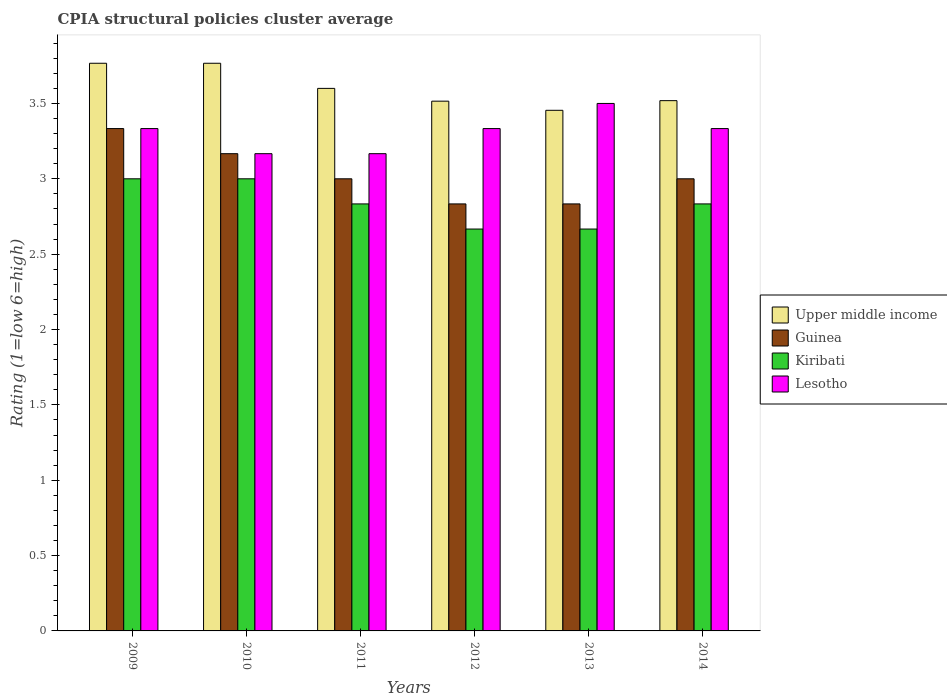How many different coloured bars are there?
Your answer should be compact. 4. How many groups of bars are there?
Offer a very short reply. 6. What is the label of the 2nd group of bars from the left?
Ensure brevity in your answer.  2010. In how many cases, is the number of bars for a given year not equal to the number of legend labels?
Your answer should be compact. 0. What is the CPIA rating in Guinea in 2014?
Offer a very short reply. 3. Across all years, what is the maximum CPIA rating in Upper middle income?
Offer a very short reply. 3.77. Across all years, what is the minimum CPIA rating in Guinea?
Provide a short and direct response. 2.83. In which year was the CPIA rating in Lesotho maximum?
Your answer should be very brief. 2013. What is the total CPIA rating in Upper middle income in the graph?
Your answer should be very brief. 21.62. What is the difference between the CPIA rating in Guinea in 2009 and that in 2013?
Provide a short and direct response. 0.5. What is the difference between the CPIA rating in Upper middle income in 2014 and the CPIA rating in Lesotho in 2009?
Make the answer very short. 0.19. What is the average CPIA rating in Lesotho per year?
Your response must be concise. 3.31. In the year 2014, what is the difference between the CPIA rating in Kiribati and CPIA rating in Guinea?
Keep it short and to the point. -0.17. In how many years, is the CPIA rating in Guinea greater than 3.1?
Keep it short and to the point. 2. What is the ratio of the CPIA rating in Upper middle income in 2011 to that in 2014?
Provide a succinct answer. 1.02. Is the CPIA rating in Kiribati in 2010 less than that in 2014?
Your response must be concise. No. What is the difference between the highest and the lowest CPIA rating in Lesotho?
Your answer should be compact. 0.33. Is the sum of the CPIA rating in Kiribati in 2013 and 2014 greater than the maximum CPIA rating in Lesotho across all years?
Your answer should be very brief. Yes. What does the 4th bar from the left in 2012 represents?
Offer a terse response. Lesotho. What does the 3rd bar from the right in 2013 represents?
Ensure brevity in your answer.  Guinea. How many bars are there?
Make the answer very short. 24. Are all the bars in the graph horizontal?
Ensure brevity in your answer.  No. How many years are there in the graph?
Make the answer very short. 6. What is the difference between two consecutive major ticks on the Y-axis?
Give a very brief answer. 0.5. Are the values on the major ticks of Y-axis written in scientific E-notation?
Provide a succinct answer. No. Does the graph contain any zero values?
Your answer should be very brief. No. What is the title of the graph?
Provide a short and direct response. CPIA structural policies cluster average. What is the label or title of the X-axis?
Make the answer very short. Years. What is the Rating (1=low 6=high) of Upper middle income in 2009?
Keep it short and to the point. 3.77. What is the Rating (1=low 6=high) in Guinea in 2009?
Offer a very short reply. 3.33. What is the Rating (1=low 6=high) in Lesotho in 2009?
Keep it short and to the point. 3.33. What is the Rating (1=low 6=high) of Upper middle income in 2010?
Offer a very short reply. 3.77. What is the Rating (1=low 6=high) of Guinea in 2010?
Ensure brevity in your answer.  3.17. What is the Rating (1=low 6=high) of Lesotho in 2010?
Your answer should be compact. 3.17. What is the Rating (1=low 6=high) in Upper middle income in 2011?
Ensure brevity in your answer.  3.6. What is the Rating (1=low 6=high) in Guinea in 2011?
Provide a short and direct response. 3. What is the Rating (1=low 6=high) in Kiribati in 2011?
Your response must be concise. 2.83. What is the Rating (1=low 6=high) of Lesotho in 2011?
Offer a very short reply. 3.17. What is the Rating (1=low 6=high) of Upper middle income in 2012?
Provide a succinct answer. 3.52. What is the Rating (1=low 6=high) in Guinea in 2012?
Make the answer very short. 2.83. What is the Rating (1=low 6=high) in Kiribati in 2012?
Provide a succinct answer. 2.67. What is the Rating (1=low 6=high) in Lesotho in 2012?
Offer a terse response. 3.33. What is the Rating (1=low 6=high) of Upper middle income in 2013?
Give a very brief answer. 3.45. What is the Rating (1=low 6=high) in Guinea in 2013?
Offer a terse response. 2.83. What is the Rating (1=low 6=high) in Kiribati in 2013?
Ensure brevity in your answer.  2.67. What is the Rating (1=low 6=high) in Upper middle income in 2014?
Your answer should be compact. 3.52. What is the Rating (1=low 6=high) in Kiribati in 2014?
Provide a short and direct response. 2.83. What is the Rating (1=low 6=high) in Lesotho in 2014?
Offer a very short reply. 3.33. Across all years, what is the maximum Rating (1=low 6=high) in Upper middle income?
Give a very brief answer. 3.77. Across all years, what is the maximum Rating (1=low 6=high) of Guinea?
Provide a succinct answer. 3.33. Across all years, what is the maximum Rating (1=low 6=high) in Kiribati?
Keep it short and to the point. 3. Across all years, what is the minimum Rating (1=low 6=high) in Upper middle income?
Give a very brief answer. 3.45. Across all years, what is the minimum Rating (1=low 6=high) in Guinea?
Offer a terse response. 2.83. Across all years, what is the minimum Rating (1=low 6=high) in Kiribati?
Keep it short and to the point. 2.67. Across all years, what is the minimum Rating (1=low 6=high) in Lesotho?
Offer a terse response. 3.17. What is the total Rating (1=low 6=high) of Upper middle income in the graph?
Provide a succinct answer. 21.62. What is the total Rating (1=low 6=high) in Guinea in the graph?
Make the answer very short. 18.17. What is the total Rating (1=low 6=high) of Lesotho in the graph?
Offer a very short reply. 19.83. What is the difference between the Rating (1=low 6=high) in Guinea in 2009 and that in 2010?
Offer a very short reply. 0.17. What is the difference between the Rating (1=low 6=high) in Lesotho in 2009 and that in 2010?
Give a very brief answer. 0.17. What is the difference between the Rating (1=low 6=high) in Upper middle income in 2009 and that in 2012?
Your answer should be very brief. 0.25. What is the difference between the Rating (1=low 6=high) of Guinea in 2009 and that in 2012?
Ensure brevity in your answer.  0.5. What is the difference between the Rating (1=low 6=high) in Kiribati in 2009 and that in 2012?
Your answer should be very brief. 0.33. What is the difference between the Rating (1=low 6=high) in Upper middle income in 2009 and that in 2013?
Give a very brief answer. 0.31. What is the difference between the Rating (1=low 6=high) of Guinea in 2009 and that in 2013?
Provide a succinct answer. 0.5. What is the difference between the Rating (1=low 6=high) in Kiribati in 2009 and that in 2013?
Provide a succinct answer. 0.33. What is the difference between the Rating (1=low 6=high) of Lesotho in 2009 and that in 2013?
Provide a succinct answer. -0.17. What is the difference between the Rating (1=low 6=high) in Upper middle income in 2009 and that in 2014?
Provide a short and direct response. 0.25. What is the difference between the Rating (1=low 6=high) in Guinea in 2009 and that in 2014?
Make the answer very short. 0.33. What is the difference between the Rating (1=low 6=high) in Kiribati in 2009 and that in 2014?
Your answer should be very brief. 0.17. What is the difference between the Rating (1=low 6=high) in Upper middle income in 2010 and that in 2011?
Make the answer very short. 0.17. What is the difference between the Rating (1=low 6=high) of Upper middle income in 2010 and that in 2012?
Provide a succinct answer. 0.25. What is the difference between the Rating (1=low 6=high) in Guinea in 2010 and that in 2012?
Give a very brief answer. 0.33. What is the difference between the Rating (1=low 6=high) in Kiribati in 2010 and that in 2012?
Give a very brief answer. 0.33. What is the difference between the Rating (1=low 6=high) in Lesotho in 2010 and that in 2012?
Keep it short and to the point. -0.17. What is the difference between the Rating (1=low 6=high) in Upper middle income in 2010 and that in 2013?
Offer a terse response. 0.31. What is the difference between the Rating (1=low 6=high) of Upper middle income in 2010 and that in 2014?
Your answer should be compact. 0.25. What is the difference between the Rating (1=low 6=high) of Guinea in 2010 and that in 2014?
Provide a succinct answer. 0.17. What is the difference between the Rating (1=low 6=high) of Lesotho in 2010 and that in 2014?
Provide a succinct answer. -0.17. What is the difference between the Rating (1=low 6=high) in Upper middle income in 2011 and that in 2012?
Your answer should be compact. 0.08. What is the difference between the Rating (1=low 6=high) in Kiribati in 2011 and that in 2012?
Provide a short and direct response. 0.17. What is the difference between the Rating (1=low 6=high) of Lesotho in 2011 and that in 2012?
Offer a very short reply. -0.17. What is the difference between the Rating (1=low 6=high) of Upper middle income in 2011 and that in 2013?
Offer a very short reply. 0.15. What is the difference between the Rating (1=low 6=high) in Upper middle income in 2011 and that in 2014?
Provide a succinct answer. 0.08. What is the difference between the Rating (1=low 6=high) in Lesotho in 2011 and that in 2014?
Offer a very short reply. -0.17. What is the difference between the Rating (1=low 6=high) in Upper middle income in 2012 and that in 2013?
Keep it short and to the point. 0.06. What is the difference between the Rating (1=low 6=high) in Lesotho in 2012 and that in 2013?
Your response must be concise. -0.17. What is the difference between the Rating (1=low 6=high) of Upper middle income in 2012 and that in 2014?
Provide a short and direct response. -0. What is the difference between the Rating (1=low 6=high) of Lesotho in 2012 and that in 2014?
Make the answer very short. 0. What is the difference between the Rating (1=low 6=high) of Upper middle income in 2013 and that in 2014?
Provide a short and direct response. -0.06. What is the difference between the Rating (1=low 6=high) of Kiribati in 2013 and that in 2014?
Your response must be concise. -0.17. What is the difference between the Rating (1=low 6=high) of Upper middle income in 2009 and the Rating (1=low 6=high) of Guinea in 2010?
Keep it short and to the point. 0.6. What is the difference between the Rating (1=low 6=high) in Upper middle income in 2009 and the Rating (1=low 6=high) in Kiribati in 2010?
Your response must be concise. 0.77. What is the difference between the Rating (1=low 6=high) in Guinea in 2009 and the Rating (1=low 6=high) in Kiribati in 2010?
Keep it short and to the point. 0.33. What is the difference between the Rating (1=low 6=high) of Upper middle income in 2009 and the Rating (1=low 6=high) of Guinea in 2011?
Your answer should be compact. 0.77. What is the difference between the Rating (1=low 6=high) in Upper middle income in 2009 and the Rating (1=low 6=high) in Kiribati in 2011?
Keep it short and to the point. 0.93. What is the difference between the Rating (1=low 6=high) in Upper middle income in 2009 and the Rating (1=low 6=high) in Lesotho in 2011?
Your answer should be compact. 0.6. What is the difference between the Rating (1=low 6=high) in Guinea in 2009 and the Rating (1=low 6=high) in Kiribati in 2011?
Provide a succinct answer. 0.5. What is the difference between the Rating (1=low 6=high) in Guinea in 2009 and the Rating (1=low 6=high) in Lesotho in 2011?
Keep it short and to the point. 0.17. What is the difference between the Rating (1=low 6=high) in Kiribati in 2009 and the Rating (1=low 6=high) in Lesotho in 2011?
Offer a terse response. -0.17. What is the difference between the Rating (1=low 6=high) in Upper middle income in 2009 and the Rating (1=low 6=high) in Lesotho in 2012?
Make the answer very short. 0.43. What is the difference between the Rating (1=low 6=high) of Guinea in 2009 and the Rating (1=low 6=high) of Kiribati in 2012?
Offer a terse response. 0.67. What is the difference between the Rating (1=low 6=high) of Guinea in 2009 and the Rating (1=low 6=high) of Lesotho in 2012?
Give a very brief answer. 0. What is the difference between the Rating (1=low 6=high) in Kiribati in 2009 and the Rating (1=low 6=high) in Lesotho in 2012?
Ensure brevity in your answer.  -0.33. What is the difference between the Rating (1=low 6=high) in Upper middle income in 2009 and the Rating (1=low 6=high) in Guinea in 2013?
Your answer should be very brief. 0.93. What is the difference between the Rating (1=low 6=high) of Upper middle income in 2009 and the Rating (1=low 6=high) of Kiribati in 2013?
Ensure brevity in your answer.  1.1. What is the difference between the Rating (1=low 6=high) in Upper middle income in 2009 and the Rating (1=low 6=high) in Lesotho in 2013?
Offer a terse response. 0.27. What is the difference between the Rating (1=low 6=high) in Guinea in 2009 and the Rating (1=low 6=high) in Kiribati in 2013?
Your answer should be very brief. 0.67. What is the difference between the Rating (1=low 6=high) in Guinea in 2009 and the Rating (1=low 6=high) in Lesotho in 2013?
Offer a terse response. -0.17. What is the difference between the Rating (1=low 6=high) in Upper middle income in 2009 and the Rating (1=low 6=high) in Guinea in 2014?
Keep it short and to the point. 0.77. What is the difference between the Rating (1=low 6=high) of Upper middle income in 2009 and the Rating (1=low 6=high) of Kiribati in 2014?
Your response must be concise. 0.93. What is the difference between the Rating (1=low 6=high) of Upper middle income in 2009 and the Rating (1=low 6=high) of Lesotho in 2014?
Offer a very short reply. 0.43. What is the difference between the Rating (1=low 6=high) of Guinea in 2009 and the Rating (1=low 6=high) of Lesotho in 2014?
Give a very brief answer. 0. What is the difference between the Rating (1=low 6=high) of Kiribati in 2009 and the Rating (1=low 6=high) of Lesotho in 2014?
Provide a succinct answer. -0.33. What is the difference between the Rating (1=low 6=high) of Upper middle income in 2010 and the Rating (1=low 6=high) of Guinea in 2011?
Make the answer very short. 0.77. What is the difference between the Rating (1=low 6=high) in Upper middle income in 2010 and the Rating (1=low 6=high) in Lesotho in 2011?
Make the answer very short. 0.6. What is the difference between the Rating (1=low 6=high) of Guinea in 2010 and the Rating (1=low 6=high) of Kiribati in 2011?
Keep it short and to the point. 0.33. What is the difference between the Rating (1=low 6=high) of Guinea in 2010 and the Rating (1=low 6=high) of Lesotho in 2011?
Give a very brief answer. 0. What is the difference between the Rating (1=low 6=high) in Upper middle income in 2010 and the Rating (1=low 6=high) in Kiribati in 2012?
Provide a succinct answer. 1.1. What is the difference between the Rating (1=low 6=high) of Upper middle income in 2010 and the Rating (1=low 6=high) of Lesotho in 2012?
Keep it short and to the point. 0.43. What is the difference between the Rating (1=low 6=high) of Guinea in 2010 and the Rating (1=low 6=high) of Lesotho in 2012?
Offer a terse response. -0.17. What is the difference between the Rating (1=low 6=high) in Kiribati in 2010 and the Rating (1=low 6=high) in Lesotho in 2012?
Your answer should be very brief. -0.33. What is the difference between the Rating (1=low 6=high) in Upper middle income in 2010 and the Rating (1=low 6=high) in Guinea in 2013?
Provide a short and direct response. 0.93. What is the difference between the Rating (1=low 6=high) of Upper middle income in 2010 and the Rating (1=low 6=high) of Lesotho in 2013?
Provide a short and direct response. 0.27. What is the difference between the Rating (1=low 6=high) in Guinea in 2010 and the Rating (1=low 6=high) in Lesotho in 2013?
Offer a terse response. -0.33. What is the difference between the Rating (1=low 6=high) in Kiribati in 2010 and the Rating (1=low 6=high) in Lesotho in 2013?
Keep it short and to the point. -0.5. What is the difference between the Rating (1=low 6=high) of Upper middle income in 2010 and the Rating (1=low 6=high) of Guinea in 2014?
Your answer should be very brief. 0.77. What is the difference between the Rating (1=low 6=high) of Upper middle income in 2010 and the Rating (1=low 6=high) of Lesotho in 2014?
Your answer should be very brief. 0.43. What is the difference between the Rating (1=low 6=high) in Guinea in 2010 and the Rating (1=low 6=high) in Kiribati in 2014?
Make the answer very short. 0.33. What is the difference between the Rating (1=low 6=high) of Guinea in 2010 and the Rating (1=low 6=high) of Lesotho in 2014?
Keep it short and to the point. -0.17. What is the difference between the Rating (1=low 6=high) of Upper middle income in 2011 and the Rating (1=low 6=high) of Guinea in 2012?
Keep it short and to the point. 0.77. What is the difference between the Rating (1=low 6=high) in Upper middle income in 2011 and the Rating (1=low 6=high) in Kiribati in 2012?
Your response must be concise. 0.93. What is the difference between the Rating (1=low 6=high) in Upper middle income in 2011 and the Rating (1=low 6=high) in Lesotho in 2012?
Provide a succinct answer. 0.27. What is the difference between the Rating (1=low 6=high) in Upper middle income in 2011 and the Rating (1=low 6=high) in Guinea in 2013?
Make the answer very short. 0.77. What is the difference between the Rating (1=low 6=high) of Upper middle income in 2011 and the Rating (1=low 6=high) of Lesotho in 2013?
Make the answer very short. 0.1. What is the difference between the Rating (1=low 6=high) of Guinea in 2011 and the Rating (1=low 6=high) of Lesotho in 2013?
Make the answer very short. -0.5. What is the difference between the Rating (1=low 6=high) of Kiribati in 2011 and the Rating (1=low 6=high) of Lesotho in 2013?
Provide a succinct answer. -0.67. What is the difference between the Rating (1=low 6=high) in Upper middle income in 2011 and the Rating (1=low 6=high) in Kiribati in 2014?
Make the answer very short. 0.77. What is the difference between the Rating (1=low 6=high) in Upper middle income in 2011 and the Rating (1=low 6=high) in Lesotho in 2014?
Give a very brief answer. 0.27. What is the difference between the Rating (1=low 6=high) of Guinea in 2011 and the Rating (1=low 6=high) of Lesotho in 2014?
Provide a succinct answer. -0.33. What is the difference between the Rating (1=low 6=high) in Kiribati in 2011 and the Rating (1=low 6=high) in Lesotho in 2014?
Provide a short and direct response. -0.5. What is the difference between the Rating (1=low 6=high) in Upper middle income in 2012 and the Rating (1=low 6=high) in Guinea in 2013?
Keep it short and to the point. 0.68. What is the difference between the Rating (1=low 6=high) in Upper middle income in 2012 and the Rating (1=low 6=high) in Kiribati in 2013?
Provide a succinct answer. 0.85. What is the difference between the Rating (1=low 6=high) of Upper middle income in 2012 and the Rating (1=low 6=high) of Lesotho in 2013?
Make the answer very short. 0.02. What is the difference between the Rating (1=low 6=high) in Guinea in 2012 and the Rating (1=low 6=high) in Kiribati in 2013?
Your response must be concise. 0.17. What is the difference between the Rating (1=low 6=high) of Kiribati in 2012 and the Rating (1=low 6=high) of Lesotho in 2013?
Offer a very short reply. -0.83. What is the difference between the Rating (1=low 6=high) in Upper middle income in 2012 and the Rating (1=low 6=high) in Guinea in 2014?
Keep it short and to the point. 0.52. What is the difference between the Rating (1=low 6=high) in Upper middle income in 2012 and the Rating (1=low 6=high) in Kiribati in 2014?
Your answer should be compact. 0.68. What is the difference between the Rating (1=low 6=high) in Upper middle income in 2012 and the Rating (1=low 6=high) in Lesotho in 2014?
Ensure brevity in your answer.  0.18. What is the difference between the Rating (1=low 6=high) of Kiribati in 2012 and the Rating (1=low 6=high) of Lesotho in 2014?
Offer a very short reply. -0.67. What is the difference between the Rating (1=low 6=high) of Upper middle income in 2013 and the Rating (1=low 6=high) of Guinea in 2014?
Give a very brief answer. 0.45. What is the difference between the Rating (1=low 6=high) in Upper middle income in 2013 and the Rating (1=low 6=high) in Kiribati in 2014?
Your response must be concise. 0.62. What is the difference between the Rating (1=low 6=high) of Upper middle income in 2013 and the Rating (1=low 6=high) of Lesotho in 2014?
Make the answer very short. 0.12. What is the difference between the Rating (1=low 6=high) of Guinea in 2013 and the Rating (1=low 6=high) of Kiribati in 2014?
Your answer should be compact. 0. What is the difference between the Rating (1=low 6=high) in Kiribati in 2013 and the Rating (1=low 6=high) in Lesotho in 2014?
Offer a very short reply. -0.67. What is the average Rating (1=low 6=high) in Upper middle income per year?
Keep it short and to the point. 3.6. What is the average Rating (1=low 6=high) in Guinea per year?
Your answer should be very brief. 3.03. What is the average Rating (1=low 6=high) in Kiribati per year?
Your answer should be compact. 2.83. What is the average Rating (1=low 6=high) in Lesotho per year?
Offer a very short reply. 3.31. In the year 2009, what is the difference between the Rating (1=low 6=high) in Upper middle income and Rating (1=low 6=high) in Guinea?
Offer a terse response. 0.43. In the year 2009, what is the difference between the Rating (1=low 6=high) of Upper middle income and Rating (1=low 6=high) of Kiribati?
Make the answer very short. 0.77. In the year 2009, what is the difference between the Rating (1=low 6=high) of Upper middle income and Rating (1=low 6=high) of Lesotho?
Your answer should be compact. 0.43. In the year 2009, what is the difference between the Rating (1=low 6=high) of Guinea and Rating (1=low 6=high) of Kiribati?
Offer a very short reply. 0.33. In the year 2009, what is the difference between the Rating (1=low 6=high) of Guinea and Rating (1=low 6=high) of Lesotho?
Offer a very short reply. 0. In the year 2010, what is the difference between the Rating (1=low 6=high) in Upper middle income and Rating (1=low 6=high) in Guinea?
Make the answer very short. 0.6. In the year 2010, what is the difference between the Rating (1=low 6=high) of Upper middle income and Rating (1=low 6=high) of Kiribati?
Your response must be concise. 0.77. In the year 2010, what is the difference between the Rating (1=low 6=high) of Guinea and Rating (1=low 6=high) of Kiribati?
Make the answer very short. 0.17. In the year 2011, what is the difference between the Rating (1=low 6=high) of Upper middle income and Rating (1=low 6=high) of Guinea?
Your answer should be compact. 0.6. In the year 2011, what is the difference between the Rating (1=low 6=high) of Upper middle income and Rating (1=low 6=high) of Kiribati?
Your answer should be compact. 0.77. In the year 2011, what is the difference between the Rating (1=low 6=high) of Upper middle income and Rating (1=low 6=high) of Lesotho?
Your answer should be very brief. 0.43. In the year 2011, what is the difference between the Rating (1=low 6=high) in Guinea and Rating (1=low 6=high) in Lesotho?
Keep it short and to the point. -0.17. In the year 2012, what is the difference between the Rating (1=low 6=high) in Upper middle income and Rating (1=low 6=high) in Guinea?
Give a very brief answer. 0.68. In the year 2012, what is the difference between the Rating (1=low 6=high) of Upper middle income and Rating (1=low 6=high) of Kiribati?
Your answer should be compact. 0.85. In the year 2012, what is the difference between the Rating (1=low 6=high) in Upper middle income and Rating (1=low 6=high) in Lesotho?
Offer a very short reply. 0.18. In the year 2012, what is the difference between the Rating (1=low 6=high) of Kiribati and Rating (1=low 6=high) of Lesotho?
Ensure brevity in your answer.  -0.67. In the year 2013, what is the difference between the Rating (1=low 6=high) of Upper middle income and Rating (1=low 6=high) of Guinea?
Your response must be concise. 0.62. In the year 2013, what is the difference between the Rating (1=low 6=high) of Upper middle income and Rating (1=low 6=high) of Kiribati?
Offer a terse response. 0.79. In the year 2013, what is the difference between the Rating (1=low 6=high) of Upper middle income and Rating (1=low 6=high) of Lesotho?
Your answer should be compact. -0.05. In the year 2014, what is the difference between the Rating (1=low 6=high) of Upper middle income and Rating (1=low 6=high) of Guinea?
Ensure brevity in your answer.  0.52. In the year 2014, what is the difference between the Rating (1=low 6=high) in Upper middle income and Rating (1=low 6=high) in Kiribati?
Your answer should be very brief. 0.69. In the year 2014, what is the difference between the Rating (1=low 6=high) in Upper middle income and Rating (1=low 6=high) in Lesotho?
Make the answer very short. 0.19. In the year 2014, what is the difference between the Rating (1=low 6=high) in Guinea and Rating (1=low 6=high) in Lesotho?
Your answer should be very brief. -0.33. What is the ratio of the Rating (1=low 6=high) of Upper middle income in 2009 to that in 2010?
Give a very brief answer. 1. What is the ratio of the Rating (1=low 6=high) of Guinea in 2009 to that in 2010?
Ensure brevity in your answer.  1.05. What is the ratio of the Rating (1=low 6=high) in Lesotho in 2009 to that in 2010?
Provide a short and direct response. 1.05. What is the ratio of the Rating (1=low 6=high) of Upper middle income in 2009 to that in 2011?
Provide a short and direct response. 1.05. What is the ratio of the Rating (1=low 6=high) of Kiribati in 2009 to that in 2011?
Give a very brief answer. 1.06. What is the ratio of the Rating (1=low 6=high) in Lesotho in 2009 to that in 2011?
Make the answer very short. 1.05. What is the ratio of the Rating (1=low 6=high) of Upper middle income in 2009 to that in 2012?
Offer a terse response. 1.07. What is the ratio of the Rating (1=low 6=high) of Guinea in 2009 to that in 2012?
Provide a succinct answer. 1.18. What is the ratio of the Rating (1=low 6=high) of Kiribati in 2009 to that in 2012?
Your answer should be very brief. 1.12. What is the ratio of the Rating (1=low 6=high) of Upper middle income in 2009 to that in 2013?
Make the answer very short. 1.09. What is the ratio of the Rating (1=low 6=high) in Guinea in 2009 to that in 2013?
Offer a very short reply. 1.18. What is the ratio of the Rating (1=low 6=high) in Kiribati in 2009 to that in 2013?
Your answer should be very brief. 1.12. What is the ratio of the Rating (1=low 6=high) of Upper middle income in 2009 to that in 2014?
Provide a succinct answer. 1.07. What is the ratio of the Rating (1=low 6=high) of Kiribati in 2009 to that in 2014?
Give a very brief answer. 1.06. What is the ratio of the Rating (1=low 6=high) of Upper middle income in 2010 to that in 2011?
Your answer should be very brief. 1.05. What is the ratio of the Rating (1=low 6=high) of Guinea in 2010 to that in 2011?
Keep it short and to the point. 1.06. What is the ratio of the Rating (1=low 6=high) of Kiribati in 2010 to that in 2011?
Provide a short and direct response. 1.06. What is the ratio of the Rating (1=low 6=high) in Lesotho in 2010 to that in 2011?
Your answer should be compact. 1. What is the ratio of the Rating (1=low 6=high) in Upper middle income in 2010 to that in 2012?
Offer a terse response. 1.07. What is the ratio of the Rating (1=low 6=high) in Guinea in 2010 to that in 2012?
Offer a terse response. 1.12. What is the ratio of the Rating (1=low 6=high) of Lesotho in 2010 to that in 2012?
Keep it short and to the point. 0.95. What is the ratio of the Rating (1=low 6=high) of Upper middle income in 2010 to that in 2013?
Provide a succinct answer. 1.09. What is the ratio of the Rating (1=low 6=high) in Guinea in 2010 to that in 2013?
Offer a very short reply. 1.12. What is the ratio of the Rating (1=low 6=high) in Kiribati in 2010 to that in 2013?
Offer a very short reply. 1.12. What is the ratio of the Rating (1=low 6=high) in Lesotho in 2010 to that in 2013?
Ensure brevity in your answer.  0.9. What is the ratio of the Rating (1=low 6=high) in Upper middle income in 2010 to that in 2014?
Your response must be concise. 1.07. What is the ratio of the Rating (1=low 6=high) of Guinea in 2010 to that in 2014?
Offer a terse response. 1.06. What is the ratio of the Rating (1=low 6=high) of Kiribati in 2010 to that in 2014?
Your answer should be compact. 1.06. What is the ratio of the Rating (1=low 6=high) of Lesotho in 2010 to that in 2014?
Keep it short and to the point. 0.95. What is the ratio of the Rating (1=low 6=high) of Upper middle income in 2011 to that in 2012?
Give a very brief answer. 1.02. What is the ratio of the Rating (1=low 6=high) in Guinea in 2011 to that in 2012?
Offer a terse response. 1.06. What is the ratio of the Rating (1=low 6=high) of Lesotho in 2011 to that in 2012?
Your response must be concise. 0.95. What is the ratio of the Rating (1=low 6=high) of Upper middle income in 2011 to that in 2013?
Your answer should be very brief. 1.04. What is the ratio of the Rating (1=low 6=high) in Guinea in 2011 to that in 2013?
Your answer should be very brief. 1.06. What is the ratio of the Rating (1=low 6=high) of Lesotho in 2011 to that in 2013?
Offer a very short reply. 0.9. What is the ratio of the Rating (1=low 6=high) of Upper middle income in 2011 to that in 2014?
Offer a terse response. 1.02. What is the ratio of the Rating (1=low 6=high) in Guinea in 2011 to that in 2014?
Make the answer very short. 1. What is the ratio of the Rating (1=low 6=high) in Kiribati in 2011 to that in 2014?
Make the answer very short. 1. What is the ratio of the Rating (1=low 6=high) in Upper middle income in 2012 to that in 2013?
Your answer should be very brief. 1.02. What is the ratio of the Rating (1=low 6=high) of Guinea in 2012 to that in 2013?
Your response must be concise. 1. What is the ratio of the Rating (1=low 6=high) of Kiribati in 2012 to that in 2013?
Your answer should be very brief. 1. What is the ratio of the Rating (1=low 6=high) in Upper middle income in 2012 to that in 2014?
Your answer should be compact. 1. What is the ratio of the Rating (1=low 6=high) in Guinea in 2012 to that in 2014?
Offer a terse response. 0.94. What is the ratio of the Rating (1=low 6=high) in Upper middle income in 2013 to that in 2014?
Provide a succinct answer. 0.98. What is the ratio of the Rating (1=low 6=high) of Kiribati in 2013 to that in 2014?
Provide a short and direct response. 0.94. What is the ratio of the Rating (1=low 6=high) of Lesotho in 2013 to that in 2014?
Your answer should be very brief. 1.05. What is the difference between the highest and the second highest Rating (1=low 6=high) in Upper middle income?
Your answer should be very brief. 0. What is the difference between the highest and the second highest Rating (1=low 6=high) of Kiribati?
Your answer should be very brief. 0. What is the difference between the highest and the lowest Rating (1=low 6=high) in Upper middle income?
Make the answer very short. 0.31. What is the difference between the highest and the lowest Rating (1=low 6=high) in Guinea?
Keep it short and to the point. 0.5. What is the difference between the highest and the lowest Rating (1=low 6=high) in Kiribati?
Give a very brief answer. 0.33. What is the difference between the highest and the lowest Rating (1=low 6=high) of Lesotho?
Keep it short and to the point. 0.33. 